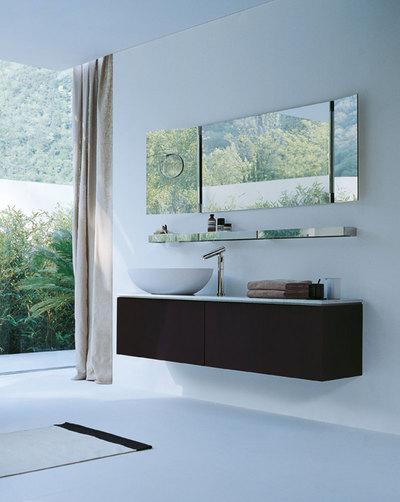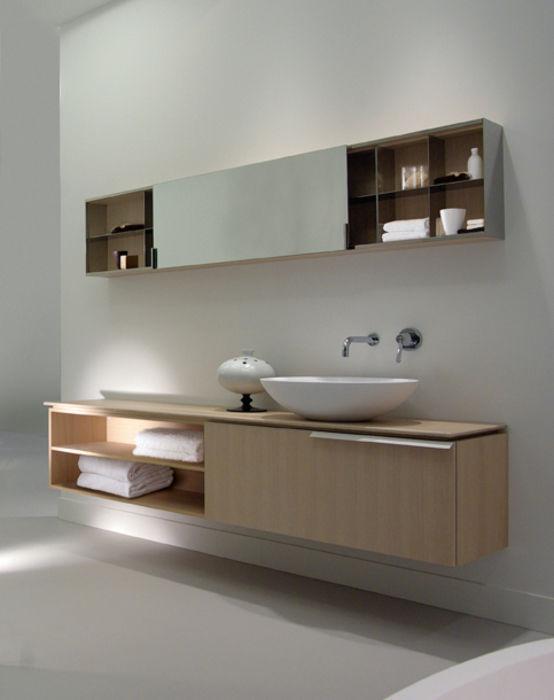The first image is the image on the left, the second image is the image on the right. For the images shown, is this caption "The left image features an aerial view of a rounded white uninstalled sink, and the right views shows the same sink shape on a counter under a black ledge with at least one bottle at the end of it." true? Answer yes or no. No. The first image is the image on the left, the second image is the image on the right. Considering the images on both sides, is "There are exactly two faucets." valid? Answer yes or no. Yes. 